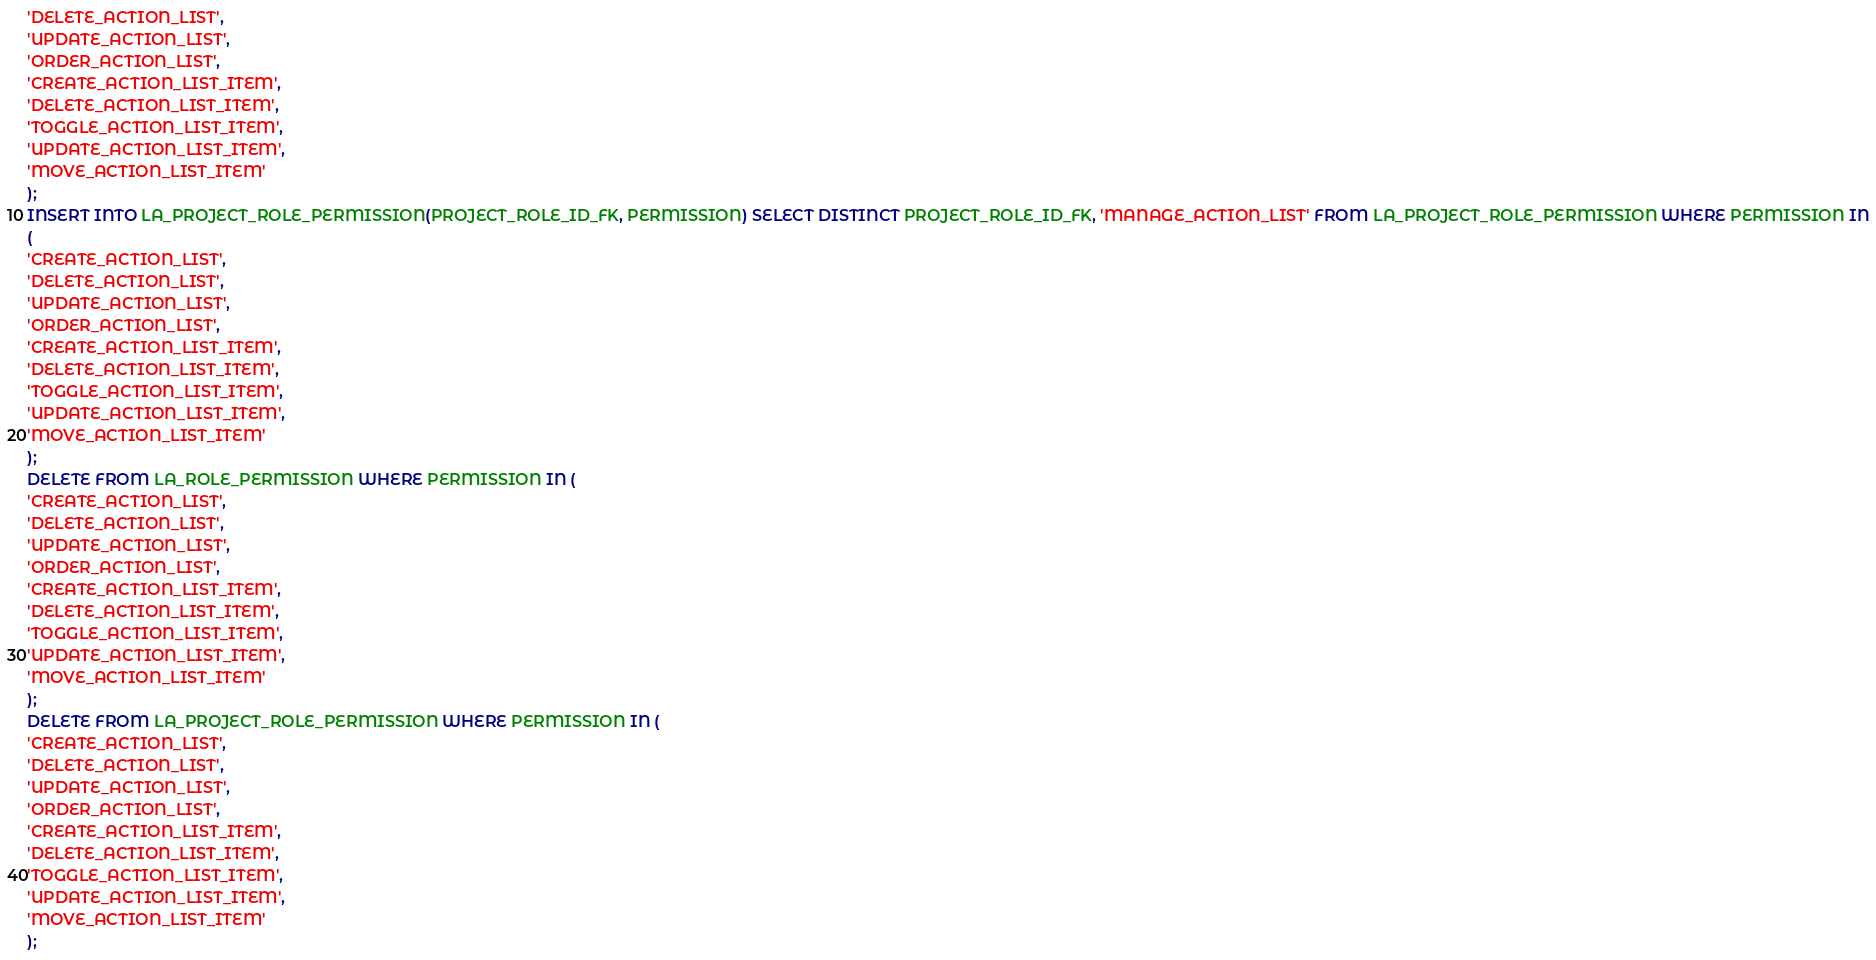<code> <loc_0><loc_0><loc_500><loc_500><_SQL_>'DELETE_ACTION_LIST',
'UPDATE_ACTION_LIST',
'ORDER_ACTION_LIST',
'CREATE_ACTION_LIST_ITEM',
'DELETE_ACTION_LIST_ITEM',
'TOGGLE_ACTION_LIST_ITEM',
'UPDATE_ACTION_LIST_ITEM',
'MOVE_ACTION_LIST_ITEM'
);
INSERT INTO LA_PROJECT_ROLE_PERMISSION(PROJECT_ROLE_ID_FK, PERMISSION) SELECT DISTINCT PROJECT_ROLE_ID_FK, 'MANAGE_ACTION_LIST' FROM LA_PROJECT_ROLE_PERMISSION WHERE PERMISSION IN
(
'CREATE_ACTION_LIST',
'DELETE_ACTION_LIST',
'UPDATE_ACTION_LIST',
'ORDER_ACTION_LIST',
'CREATE_ACTION_LIST_ITEM',
'DELETE_ACTION_LIST_ITEM',
'TOGGLE_ACTION_LIST_ITEM',
'UPDATE_ACTION_LIST_ITEM',
'MOVE_ACTION_LIST_ITEM'
);
DELETE FROM LA_ROLE_PERMISSION WHERE PERMISSION IN (
'CREATE_ACTION_LIST',
'DELETE_ACTION_LIST',
'UPDATE_ACTION_LIST',
'ORDER_ACTION_LIST',
'CREATE_ACTION_LIST_ITEM',
'DELETE_ACTION_LIST_ITEM',
'TOGGLE_ACTION_LIST_ITEM',
'UPDATE_ACTION_LIST_ITEM',
'MOVE_ACTION_LIST_ITEM'
);
DELETE FROM LA_PROJECT_ROLE_PERMISSION WHERE PERMISSION IN (
'CREATE_ACTION_LIST',
'DELETE_ACTION_LIST',
'UPDATE_ACTION_LIST',
'ORDER_ACTION_LIST',
'CREATE_ACTION_LIST_ITEM',
'DELETE_ACTION_LIST_ITEM',
'TOGGLE_ACTION_LIST_ITEM',
'UPDATE_ACTION_LIST_ITEM',
'MOVE_ACTION_LIST_ITEM'
);
</code> 